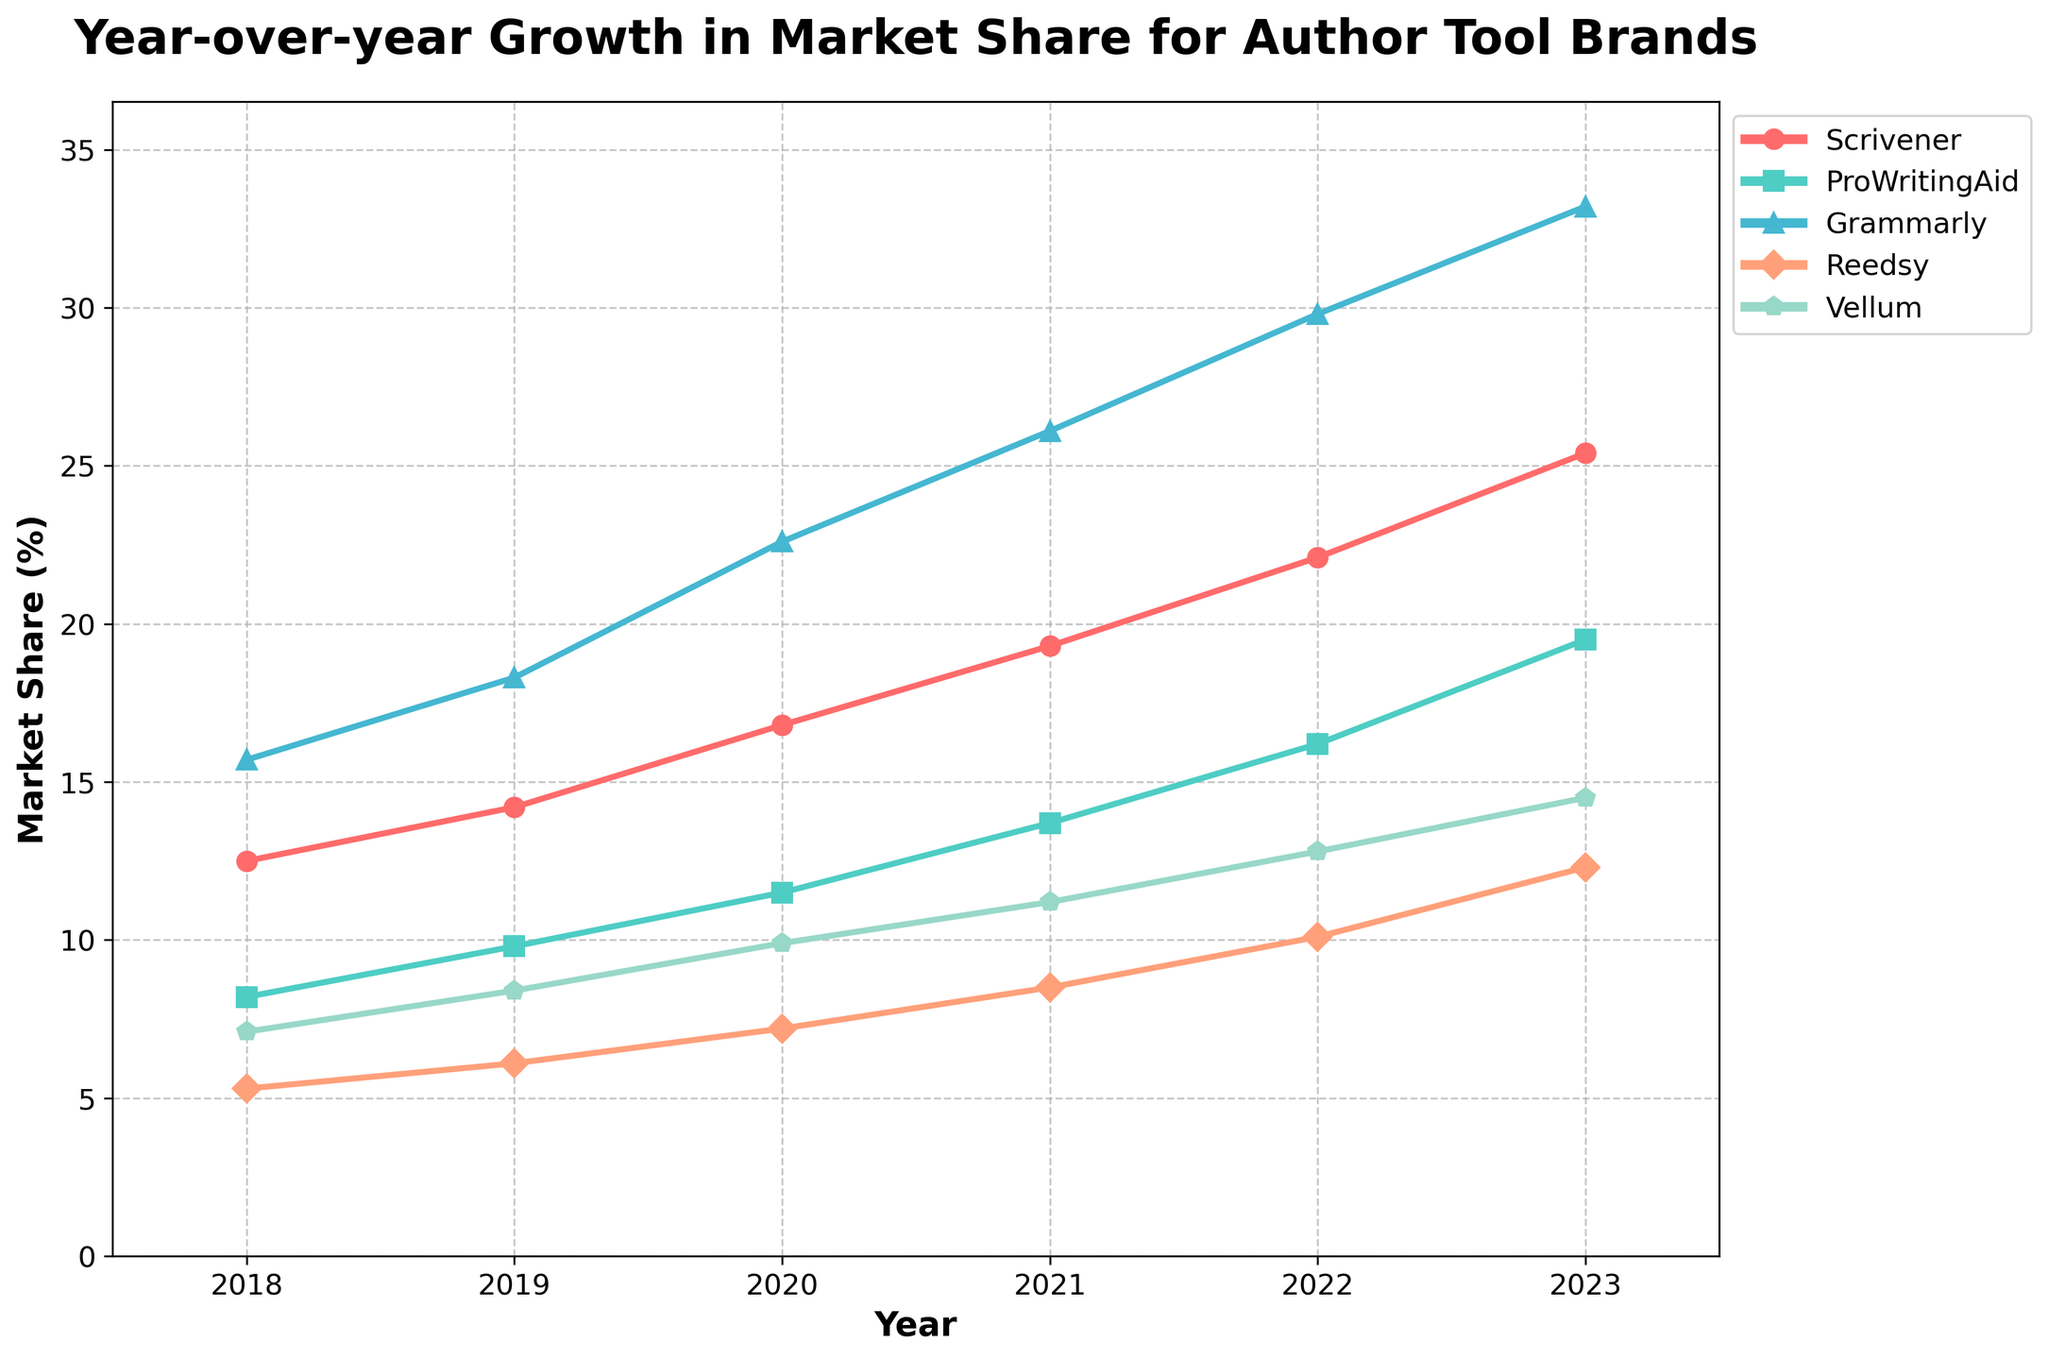What is the trend in market share for Scrivener from 2018 to 2023? To find the trend for Scrivener, observe its market share percentages over the years. Starting from 12.5% in 2018, Scrivener's market share increases incrementally each year, reaching 25.4% in 2023. This indicates a consistent upward trend in its market share.
Answer: Consistent upward Which author tool had the highest market share in 2023? To determine the author tool with the highest market share in 2023, compare the market share percentages of all tools in that year. Grammarly has the highest percentage, 33.2%, in 2023.
Answer: Grammarly Which year showed the largest increase in market share for ProWritingAid? To find the year with the largest increase for ProWritingAid, calculate the yearly differences in market share: 2018-2019 (1.6), 2019-2020 (1.7), 2020-2021 (2.2), 2021-2022 (2.5), 2022-2023 (3.3). The largest increase occurs between 2022 and 2023.
Answer: 2022-2023 By how much did Vellum's market share increase from 2018 to 2023? Calculate the difference between Vellum's market share in 2023 and 2018. In 2023, it is 14.5%, and in 2018, it was 7.1%. So, the increase is 14.5 - 7.1 = 7.4%.
Answer: 7.4% In which years did Reedsy have a market share below 8%? Identify the years where Reedsy's market share was below 8%. Based on the data, Reedsy had shares of 5.3% in 2018, 6.1% in 2019, and 7.2% in 2020.
Answer: 2018, 2019, 2020 How much did the total market share of all tools combined grow from 2018 to 2023? To find the overall growth, sum the market shares for all tools in 2018 and in 2023, then subtract the 2018 total from the 2023 total. In 2018: 12.5+8.2+15.7+5.3+7.1=48.8%. In 2023: 25.4+19.5+33.2+12.3+14.5=104.9%. Therefore, the growth is 104.9 - 48.8 = 56.1%.
Answer: 56.1% Which tool had the smallest market share in 2021, and what was its value? To find the tool with the smallest market share in 2021, compare the market share percentages of all tools for that year. Reedsy has the smallest market share at 8.5% in 2021.
Answer: Reedsy, 8.5% How does the market share growth of Grammarly compare to that of Vellum from 2020 to 2023? To compare, calculate the growth for each tool between 2020 and 2023. For Grammarly: 33.2% - 22.6% = 10.6%. For Vellum: 14.5% - 9.9% = 4.6%. Thus, Grammarly’s growth (10.6%) is larger than Vellum’s growth (4.6%) during the period.
Answer: Grammarly’s growth is larger What's the average market share of ProWritingAid over the 6-year period? To determine the average, sum ProWritingAid's market shares from 2018 to 2023 and divide by the number of years. (8.2 + 9.8 + 11.5 + 13.7 + 16.2 + 19.5) / 6 = 13.15%.
Answer: 13.15% 